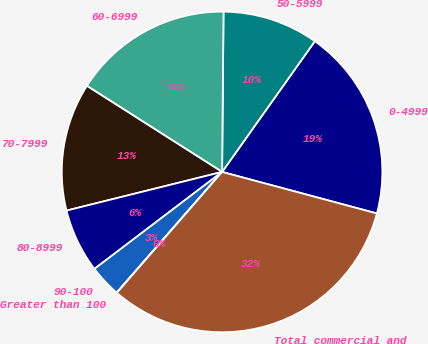Convert chart. <chart><loc_0><loc_0><loc_500><loc_500><pie_chart><fcel>0-4999<fcel>50-5999<fcel>60-6999<fcel>70-7999<fcel>80-8999<fcel>90-100<fcel>Greater than 100<fcel>Total commercial and<nl><fcel>19.35%<fcel>9.68%<fcel>16.12%<fcel>12.9%<fcel>6.46%<fcel>3.24%<fcel>0.02%<fcel>32.23%<nl></chart> 